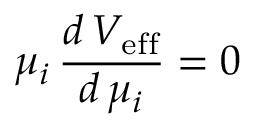<formula> <loc_0><loc_0><loc_500><loc_500>\mu _ { i } \, \frac { d \, V _ { e f f } } { d \, \mu _ { i } } = 0</formula> 